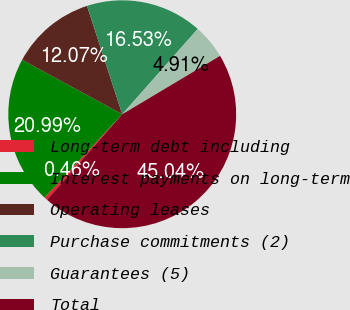<chart> <loc_0><loc_0><loc_500><loc_500><pie_chart><fcel>Long-term debt including<fcel>Interest payments on long-term<fcel>Operating leases<fcel>Purchase commitments (2)<fcel>Guarantees (5)<fcel>Total<nl><fcel>0.46%<fcel>20.99%<fcel>12.07%<fcel>16.53%<fcel>4.91%<fcel>45.04%<nl></chart> 